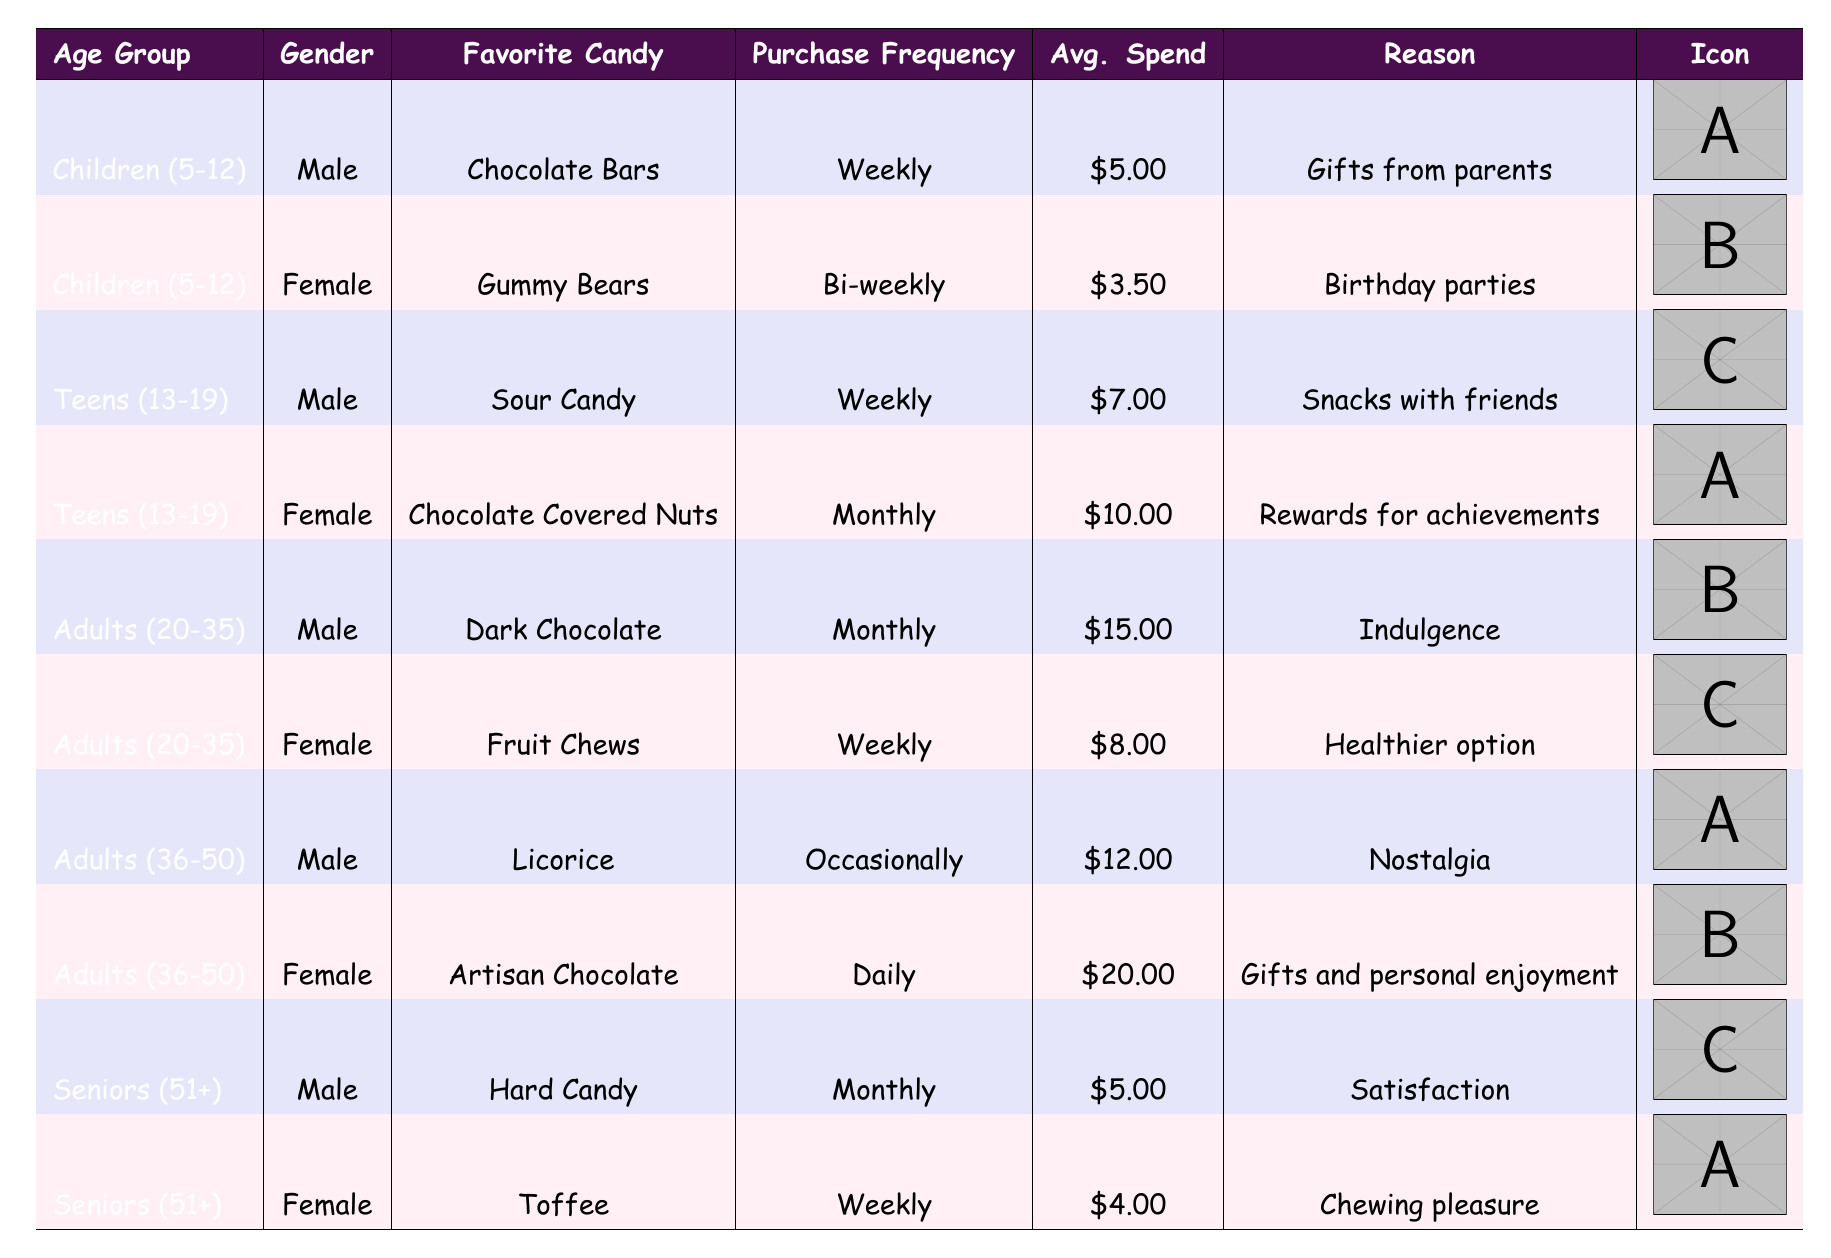What is the favorite candy of male teens? The table shows that male teens (13-19 years) have "Sour Candy" as their favorite candy.
Answer: Sour Candy How often do adult females aged 20-35 purchase candy? According to the table, adult females (20-35 years) purchase candy weekly.
Answer: Weekly What is the average spend per visit for adult males aged 36-50? The table indicates that adult males (36-50 years) have an average spend of $12.00 per visit.
Answer: $12.00 Do seniors prefer hard candy over toffee? The table shows that male seniors prefer "Hard Candy" while female seniors prefer "Toffee." Thus, it's not a clear preference for hard candy overall.
Answer: No What is the total average spend per visit for children aged 5-12? The average spend for boys is $5.00 and for girls is $3.50. So, the total is $5.00 + $3.50 = $8.50. The average is $8.50 / 2 = $4.25.
Answer: $4.25 How many different favorite candies are listed for adults aged 20-35? The table shows two favorite candies for adults aged 20-35: "Dark Chocolate" and "Fruit Chews." Therefore, there are two favorite candies for that age group.
Answer: 2 What percentage of seniors purchases candy weekly? From the table, one out of two senior entries purchases candy weekly (female with Toffee), so the percentage is (1/2) * 100 = 50%.
Answer: 50% What is the reason given for the purchase of artisan chocolate by females aged 36-50? The table states that females in the 36-50 age group purchase "Artisan Chocolate" for gifts and personal enjoyment.
Answer: Gifts and personal enjoyment How does the purchase frequency of chocolate bars compare to gummy bears? Chocolate bars are purchased weekly, while gummy bears are purchased bi-weekly. Weekly purchases are more frequent than bi-weekly.
Answer: Weekly > Bi-weekly 